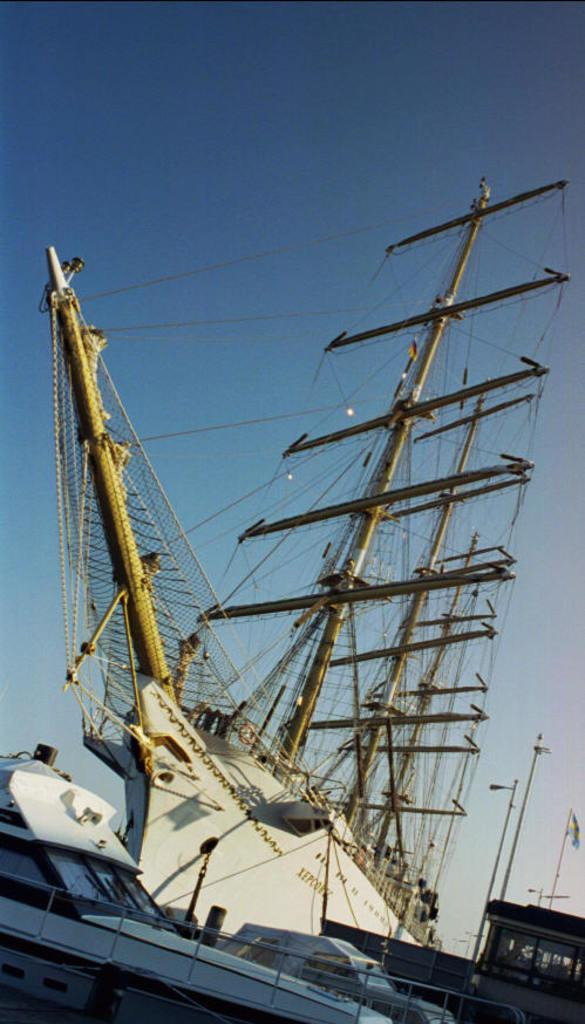What is the main subject of the picture? The main subject of the picture is a huge ship. Are there any other boats or ships in the picture? Yes, there are yachts in the picture, located on the left side. What is the condition of the sky in the picture? The sky is clear in the picture. What date is marked on the calendar in the image? There is no calendar present in the image. Can you hear the sound of the waves crashing against the ship in the image? The image is silent, and we cannot hear any sounds. 